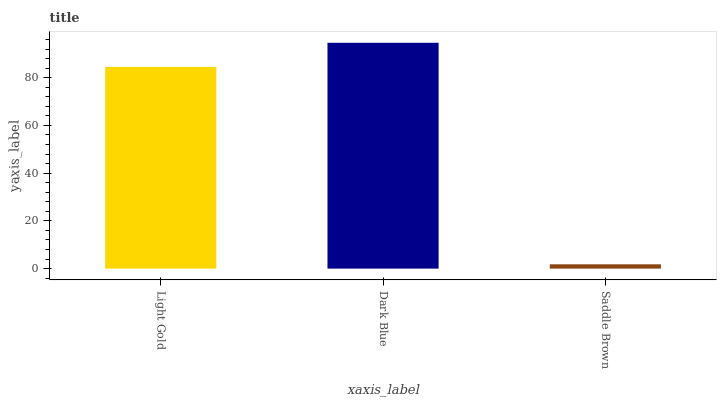Is Saddle Brown the minimum?
Answer yes or no. Yes. Is Dark Blue the maximum?
Answer yes or no. Yes. Is Dark Blue the minimum?
Answer yes or no. No. Is Saddle Brown the maximum?
Answer yes or no. No. Is Dark Blue greater than Saddle Brown?
Answer yes or no. Yes. Is Saddle Brown less than Dark Blue?
Answer yes or no. Yes. Is Saddle Brown greater than Dark Blue?
Answer yes or no. No. Is Dark Blue less than Saddle Brown?
Answer yes or no. No. Is Light Gold the high median?
Answer yes or no. Yes. Is Light Gold the low median?
Answer yes or no. Yes. Is Dark Blue the high median?
Answer yes or no. No. Is Saddle Brown the low median?
Answer yes or no. No. 